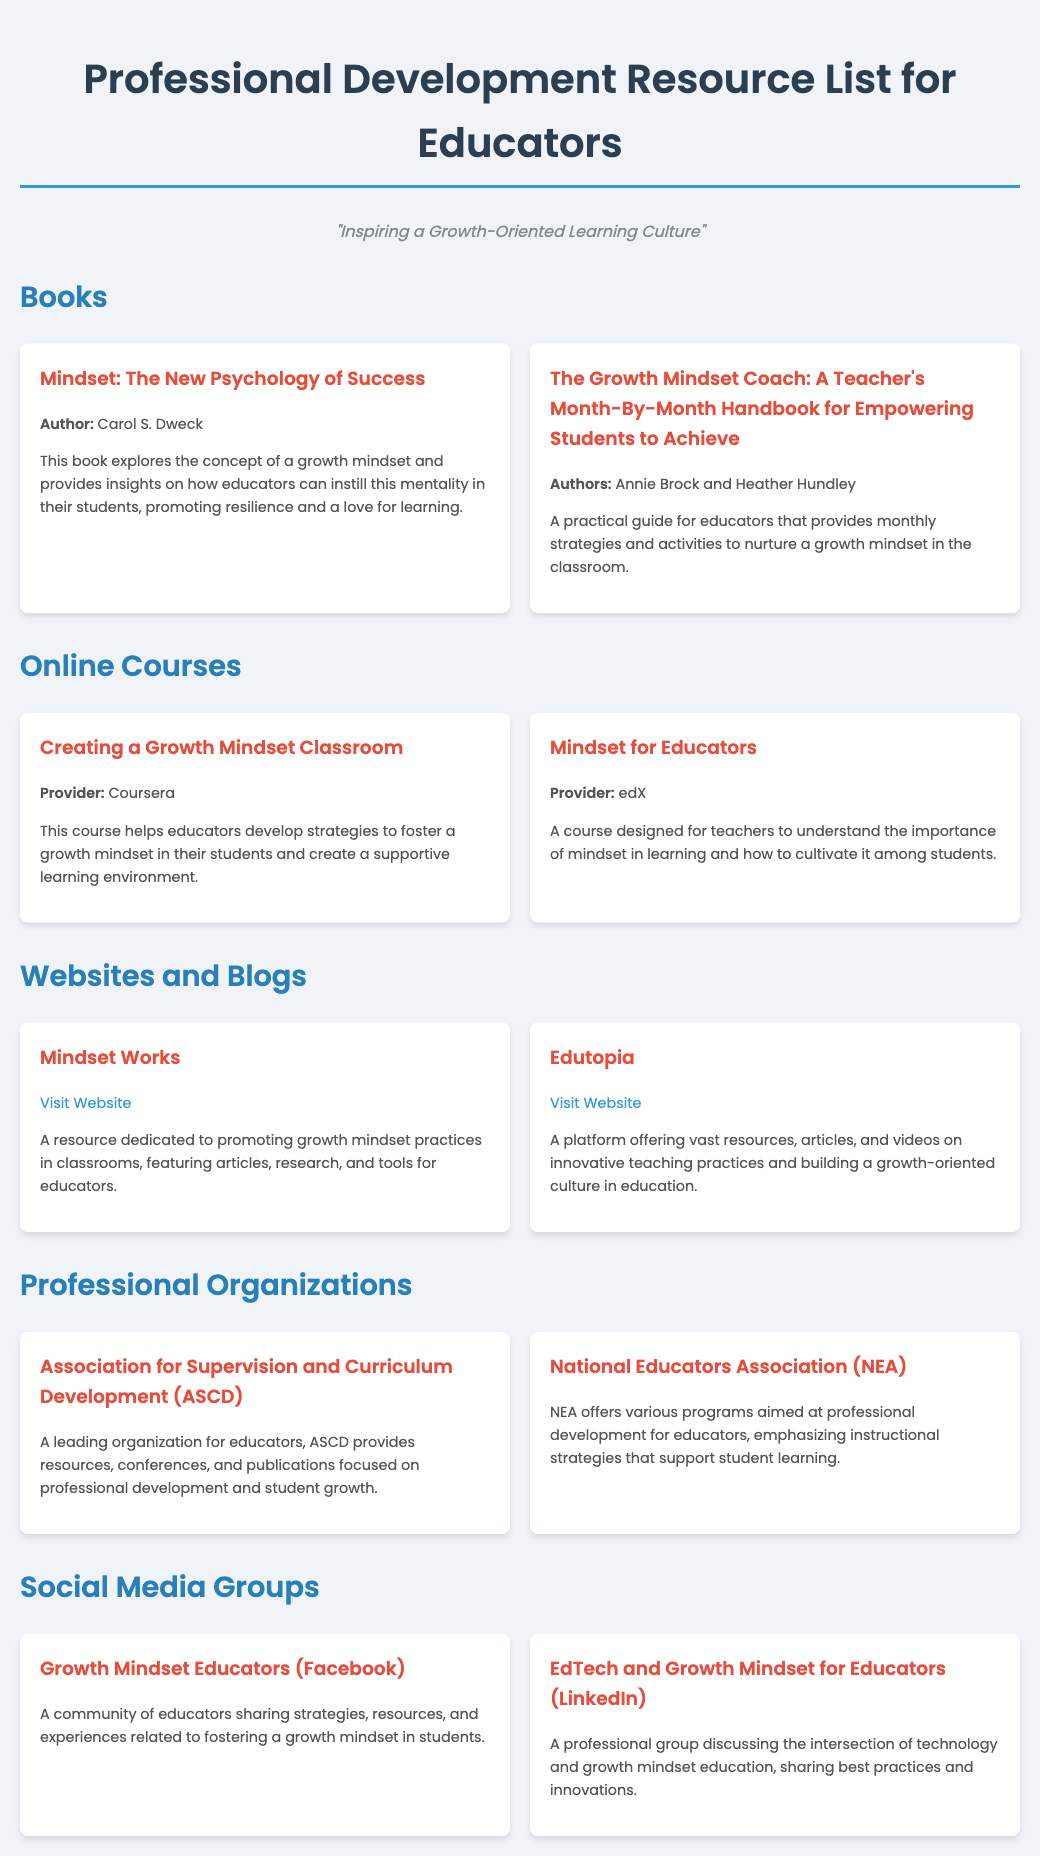What is the title of the first book listed? The title of the first book is found in the "Books" section, specifically the resource item at the top.
Answer: Mindset: The New Psychology of Success Who are the authors of "The Growth Mindset Coach"? The authors are noted in the resource item description under the "Books" section.
Answer: Annie Brock and Heather Hundley What online course is provided by Coursera? The course offered by Coursera can be identified within the "Online Courses" section specifically under its title.
Answer: Creating a Growth Mindset Classroom What organization is abbreviated as ASCD? The abbreviation ASCD stands for a specific professional organization mentioned in the "Professional Organizations" section.
Answer: Association for Supervision and Curriculum Development How many social media groups are listed in the document? The number of social media groups can be counted within the "Social Media Groups" section of the document.
Answer: 2 What is the primary focus of Mindset Works? The focus of Mindset Works is described within its resource item.
Answer: Promoting growth mindset practices What type of resource is Edutopia? The document specifies what kind of resource Edutopia is in the "Websites and Blogs" section.
Answer: A platform What does NEA stand for? The acronym NEA is explained in the "Professional Organizations" section of the document.
Answer: National Educators Association 